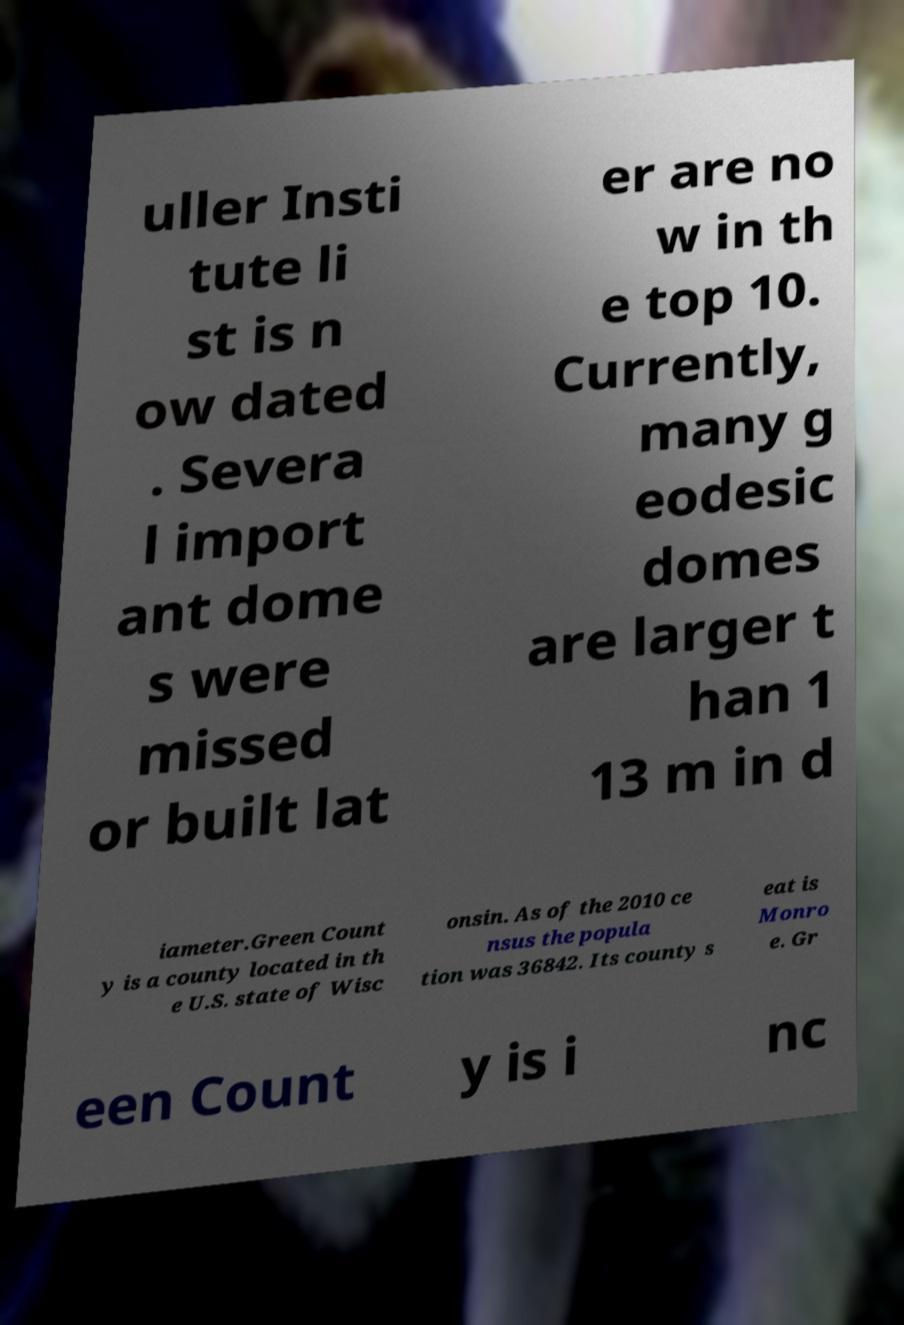What messages or text are displayed in this image? I need them in a readable, typed format. uller Insti tute li st is n ow dated . Severa l import ant dome s were missed or built lat er are no w in th e top 10. Currently, many g eodesic domes are larger t han 1 13 m in d iameter.Green Count y is a county located in th e U.S. state of Wisc onsin. As of the 2010 ce nsus the popula tion was 36842. Its county s eat is Monro e. Gr een Count y is i nc 